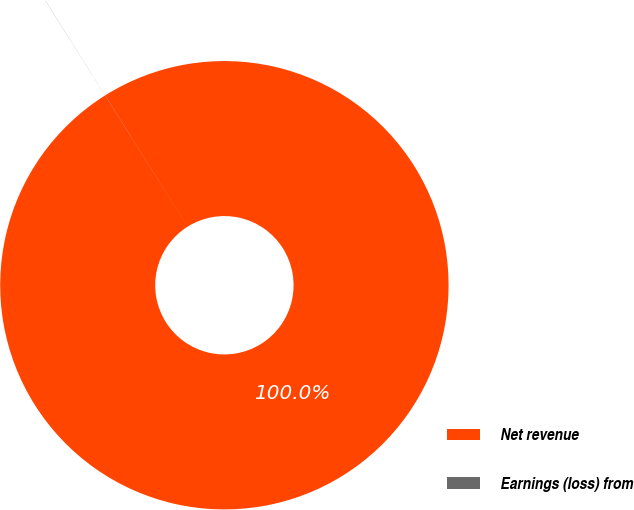<chart> <loc_0><loc_0><loc_500><loc_500><pie_chart><fcel>Net revenue<fcel>Earnings (loss) from<nl><fcel>99.99%<fcel>0.01%<nl></chart> 